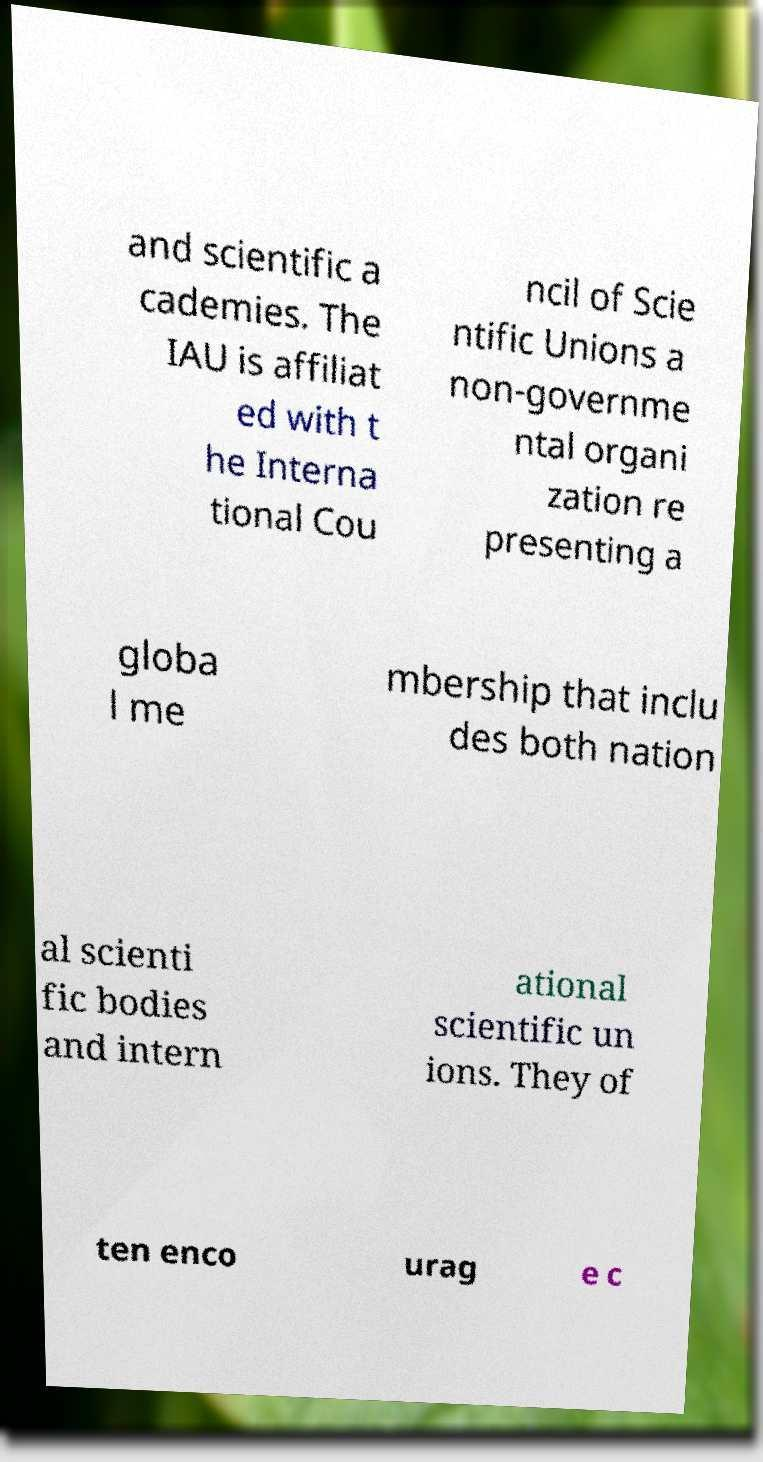For documentation purposes, I need the text within this image transcribed. Could you provide that? and scientific a cademies. The IAU is affiliat ed with t he Interna tional Cou ncil of Scie ntific Unions a non-governme ntal organi zation re presenting a globa l me mbership that inclu des both nation al scienti fic bodies and intern ational scientific un ions. They of ten enco urag e c 